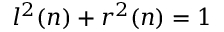Convert formula to latex. <formula><loc_0><loc_0><loc_500><loc_500>l ^ { 2 } ( n ) + r ^ { 2 } ( n ) = 1</formula> 